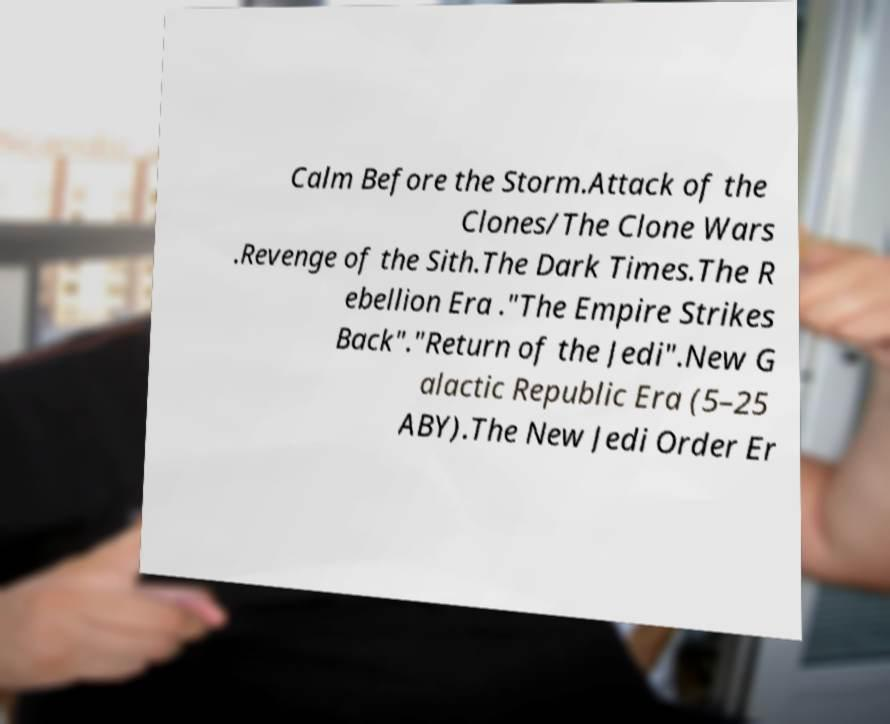Can you accurately transcribe the text from the provided image for me? Calm Before the Storm.Attack of the Clones/The Clone Wars .Revenge of the Sith.The Dark Times.The R ebellion Era ."The Empire Strikes Back"."Return of the Jedi".New G alactic Republic Era (5–25 ABY).The New Jedi Order Er 